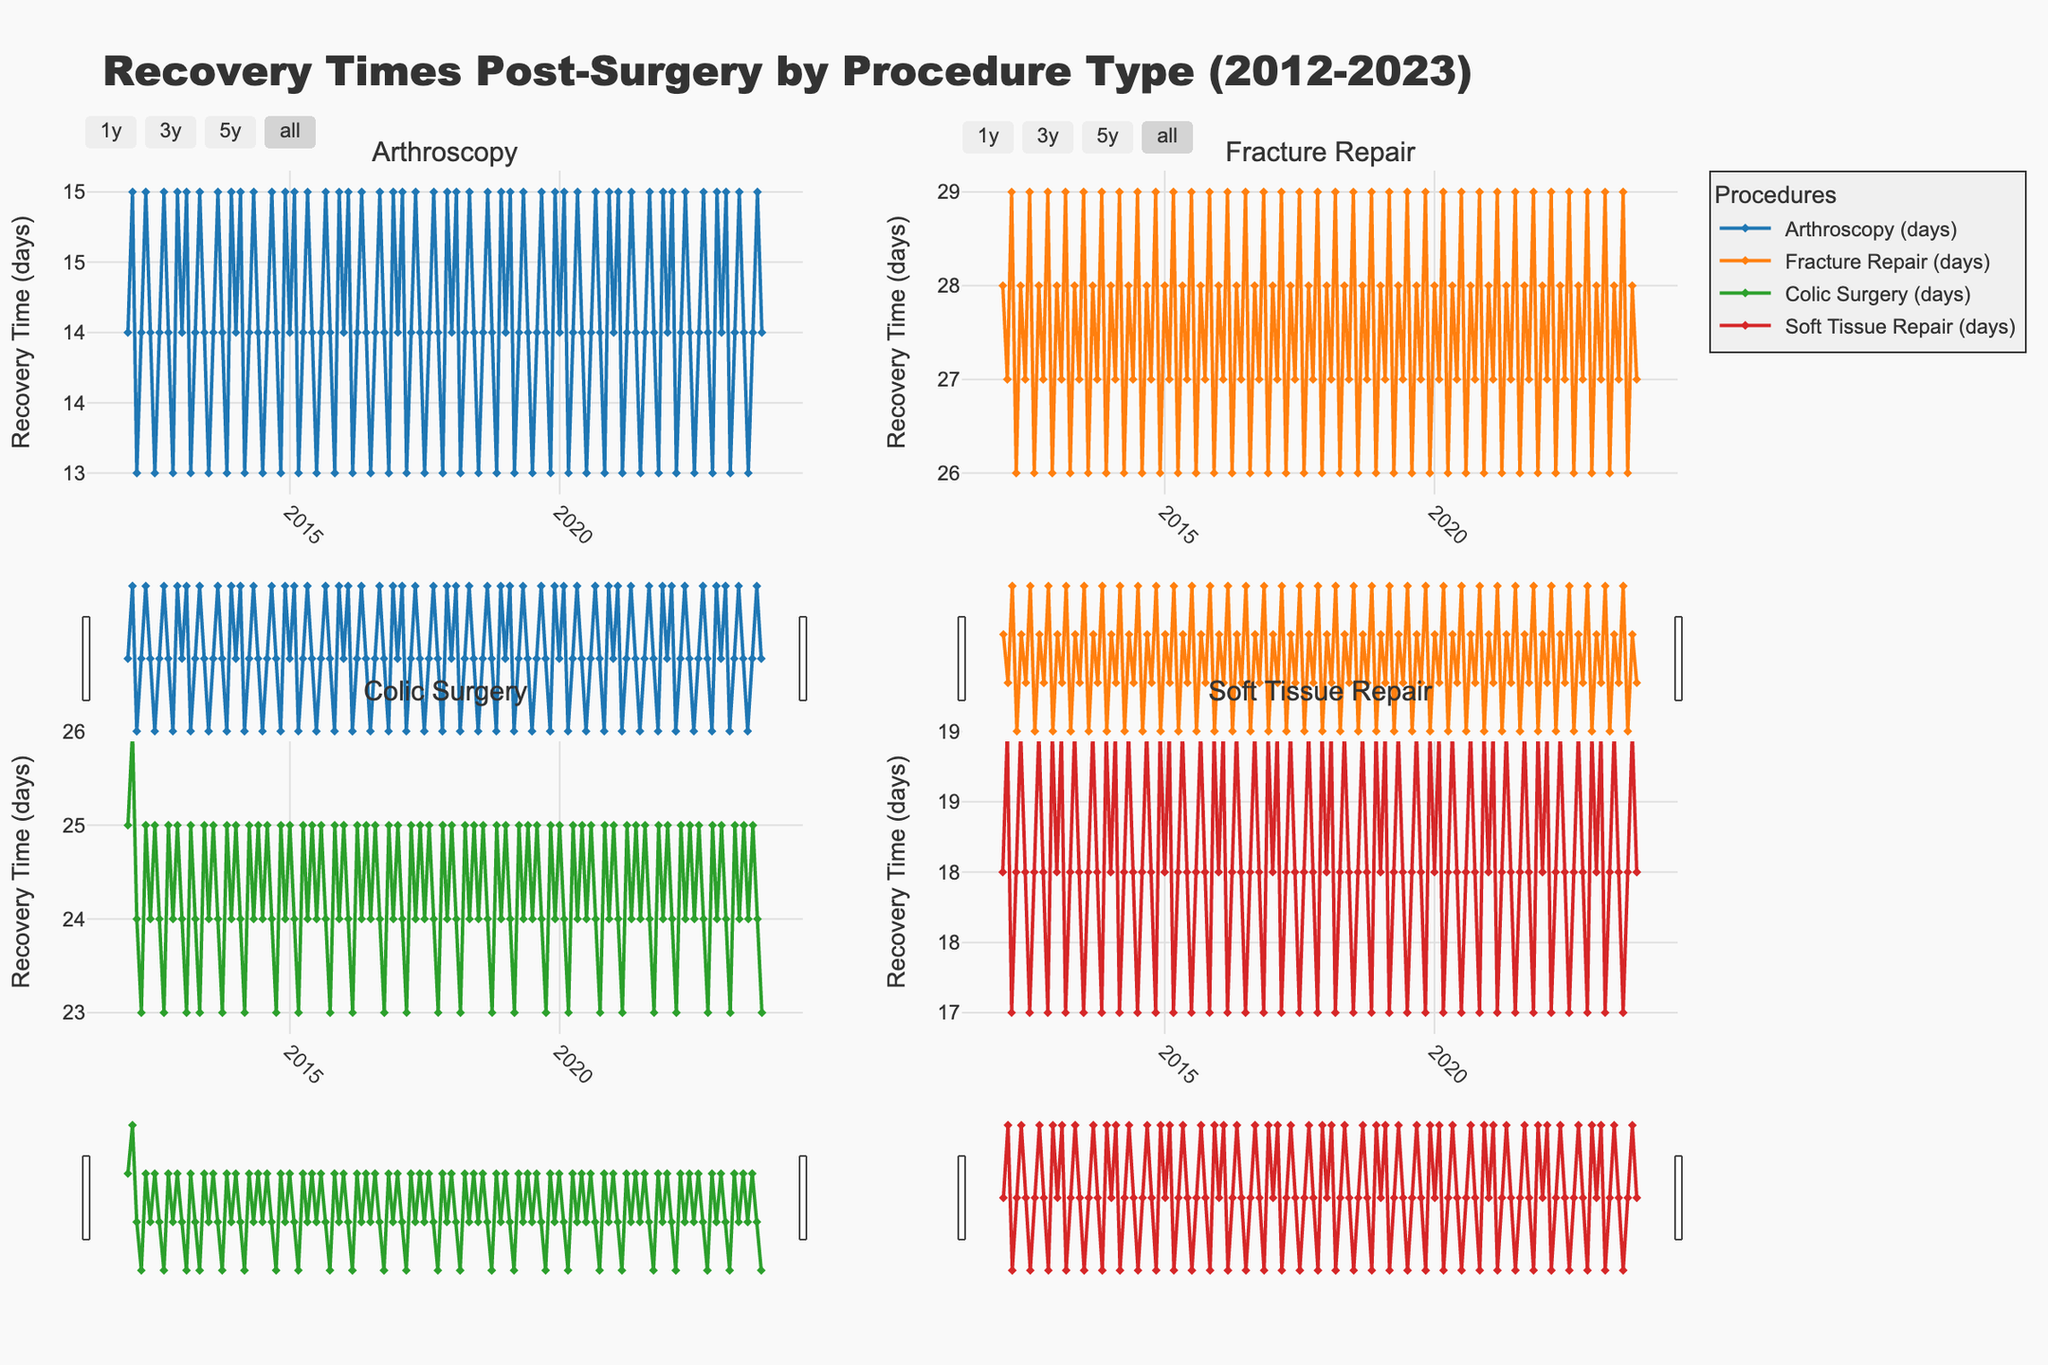What is the overall trend in recovery times for Arthroscopy over the 10 years? The recovery times for Arthroscopy fluctuate slightly but generally stay within the range of 13 to 15 days consistently throughout the 10-year period.
Answer: Consistent within 13-15 days Which procedure has the highest average recovery time across all years? To determine this, compare the average recovery times of each procedure plotted on the subplots. Fracture Repair shows consistently higher values compared to the other procedures, staying around 28-29 days.
Answer: Fracture Repair During which years does Colic Surgery show a noticeable fluctuation in recovery times? Check the subplot for Colic Surgery to identify years with the most variation. Noticeable fluctuations can be seen around 2012-2013 and 2016-2017.
Answer: 2012-2013 and 2016-2017 How do the recovery times for Fracture Repair compare to those for Soft Tissue Repair? By comparing the two subplots, Fracture Repair consistently has higher recovery times than Soft Tissue Repair. Fracture Repair is around 28-29 days, while Soft Tissue Repair is around 17-19 days.
Answer: Fracture Repair is consistently higher Are there any months where Arthroscopy recovery times peak noticeably higher than the average? Examine the subplot for any months with peaks in recovery times. In the provided data, there aren't significant peaks; it stays within 13 to 15 days.
Answer: No significant peaks Is there any seasonal pattern visible across the recovery times for any of the procedures? Checking the timing of peaks and troughs in the subplots for patterns related to seasons. No clear seasonal pattern is visible in the recovered times across the different procedures.
Answer: No clear seasonal pattern What is the range of recovery times for Soft Tissue Repair from 2012 to 2023? To determine this, identify the minimum and maximum values in the subplot for Soft Tissue Repair. The range is from 17 to 19 days.
Answer: 17-19 days Which procedure has the least variation in recovery times over the decade? Examine the subplots for each procedure to see which has the least fluctuation. Arthroscopy shows the least variation, consistently sitting between 13-15 days.
Answer: Arthroscopy How does the recovery time for Colic Surgery in 2015 compare to that in 2020? Locate the points for both years in the Colic Surgery subplot. In both 2015 and 2020, the recovery time for Colic Surgery is around 25 days.
Answer: Similar, around 25 days What are the recovery times for Fracture Repair at the beginning and end of the data period? Identify the first and last data points in the Fracture Repair subplot. The recovery times are 28 days (January 2012) and 27 days (October 2023).
Answer: 28 days and 27 days 